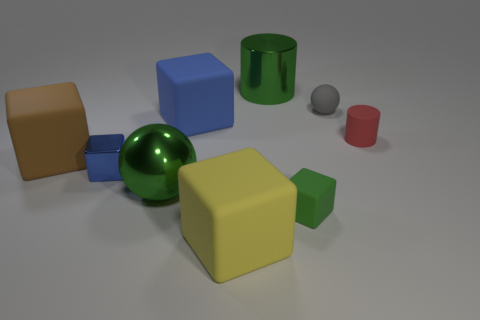Subtract all brown blocks. How many blocks are left? 4 Subtract all small metal blocks. How many blocks are left? 4 Subtract all gray blocks. Subtract all blue cylinders. How many blocks are left? 5 Add 1 brown matte cubes. How many objects exist? 10 Subtract all cylinders. How many objects are left? 7 Subtract 1 green blocks. How many objects are left? 8 Subtract all brown things. Subtract all large brown rubber things. How many objects are left? 7 Add 3 big green cylinders. How many big green cylinders are left? 4 Add 7 small red shiny spheres. How many small red shiny spheres exist? 7 